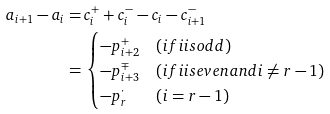Convert formula to latex. <formula><loc_0><loc_0><loc_500><loc_500>a _ { i + 1 } - a _ { i } = & \, c _ { i } ^ { + } + c _ { i } ^ { - } - c _ { i } - c _ { i + 1 } ^ { - } \\ = & \, \begin{cases} - p _ { i + 2 } ^ { + } & ( i f i i s o d d ) \\ - p _ { i + 3 } ^ { \mp } & ( i f i i s e v e n a n d i \neq r - 1 ) \\ - p _ { r } ^ { \cdot } & ( i = r - 1 ) \end{cases}</formula> 